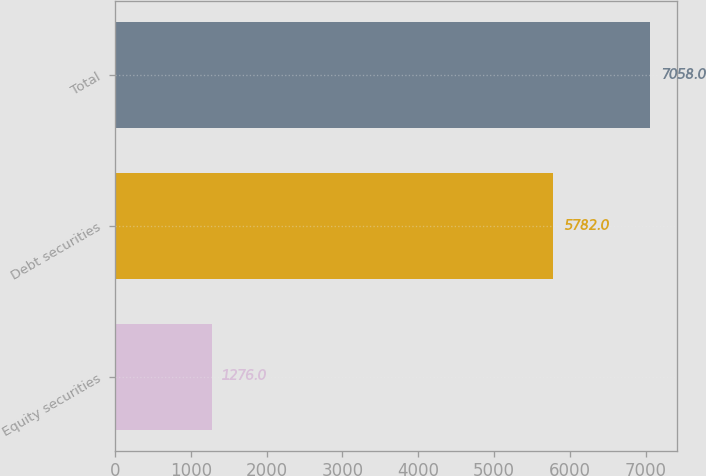Convert chart. <chart><loc_0><loc_0><loc_500><loc_500><bar_chart><fcel>Equity securities<fcel>Debt securities<fcel>Total<nl><fcel>1276<fcel>5782<fcel>7058<nl></chart> 